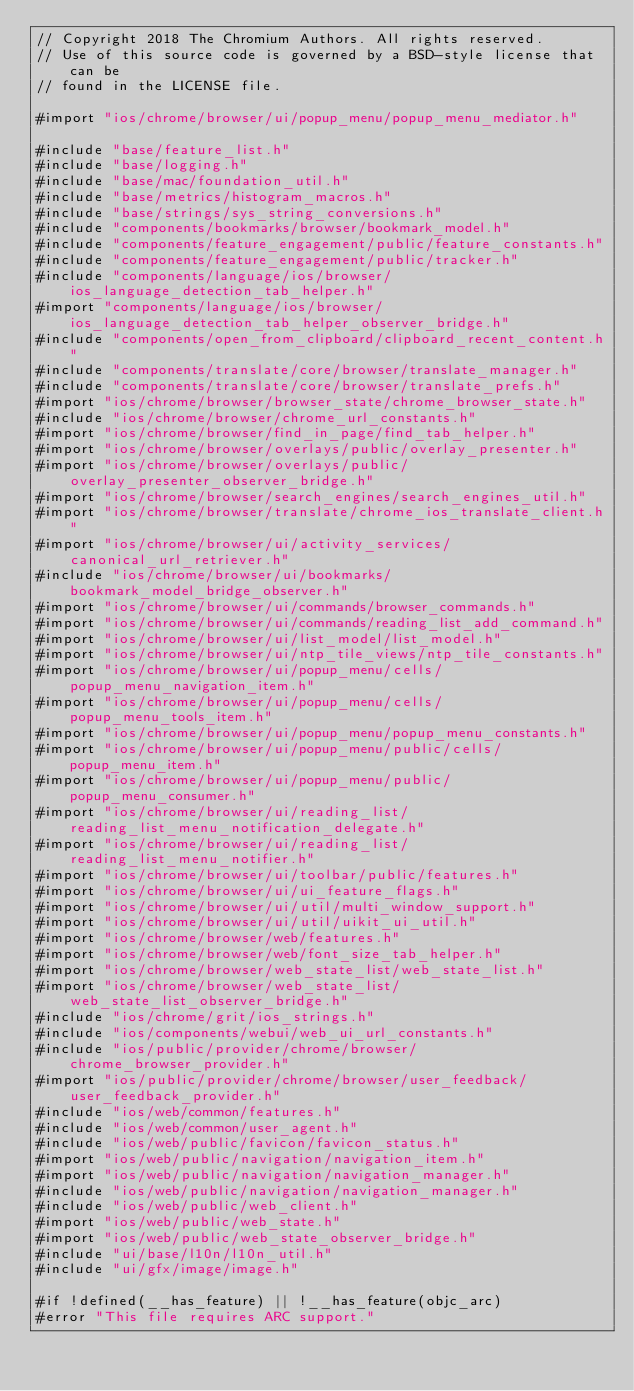<code> <loc_0><loc_0><loc_500><loc_500><_ObjectiveC_>// Copyright 2018 The Chromium Authors. All rights reserved.
// Use of this source code is governed by a BSD-style license that can be
// found in the LICENSE file.

#import "ios/chrome/browser/ui/popup_menu/popup_menu_mediator.h"

#include "base/feature_list.h"
#include "base/logging.h"
#include "base/mac/foundation_util.h"
#include "base/metrics/histogram_macros.h"
#include "base/strings/sys_string_conversions.h"
#include "components/bookmarks/browser/bookmark_model.h"
#include "components/feature_engagement/public/feature_constants.h"
#include "components/feature_engagement/public/tracker.h"
#include "components/language/ios/browser/ios_language_detection_tab_helper.h"
#import "components/language/ios/browser/ios_language_detection_tab_helper_observer_bridge.h"
#include "components/open_from_clipboard/clipboard_recent_content.h"
#include "components/translate/core/browser/translate_manager.h"
#include "components/translate/core/browser/translate_prefs.h"
#import "ios/chrome/browser/browser_state/chrome_browser_state.h"
#include "ios/chrome/browser/chrome_url_constants.h"
#import "ios/chrome/browser/find_in_page/find_tab_helper.h"
#import "ios/chrome/browser/overlays/public/overlay_presenter.h"
#import "ios/chrome/browser/overlays/public/overlay_presenter_observer_bridge.h"
#import "ios/chrome/browser/search_engines/search_engines_util.h"
#import "ios/chrome/browser/translate/chrome_ios_translate_client.h"
#import "ios/chrome/browser/ui/activity_services/canonical_url_retriever.h"
#include "ios/chrome/browser/ui/bookmarks/bookmark_model_bridge_observer.h"
#import "ios/chrome/browser/ui/commands/browser_commands.h"
#import "ios/chrome/browser/ui/commands/reading_list_add_command.h"
#import "ios/chrome/browser/ui/list_model/list_model.h"
#import "ios/chrome/browser/ui/ntp_tile_views/ntp_tile_constants.h"
#import "ios/chrome/browser/ui/popup_menu/cells/popup_menu_navigation_item.h"
#import "ios/chrome/browser/ui/popup_menu/cells/popup_menu_tools_item.h"
#import "ios/chrome/browser/ui/popup_menu/popup_menu_constants.h"
#import "ios/chrome/browser/ui/popup_menu/public/cells/popup_menu_item.h"
#import "ios/chrome/browser/ui/popup_menu/public/popup_menu_consumer.h"
#import "ios/chrome/browser/ui/reading_list/reading_list_menu_notification_delegate.h"
#import "ios/chrome/browser/ui/reading_list/reading_list_menu_notifier.h"
#import "ios/chrome/browser/ui/toolbar/public/features.h"
#import "ios/chrome/browser/ui/ui_feature_flags.h"
#import "ios/chrome/browser/ui/util/multi_window_support.h"
#import "ios/chrome/browser/ui/util/uikit_ui_util.h"
#import "ios/chrome/browser/web/features.h"
#import "ios/chrome/browser/web/font_size_tab_helper.h"
#import "ios/chrome/browser/web_state_list/web_state_list.h"
#import "ios/chrome/browser/web_state_list/web_state_list_observer_bridge.h"
#include "ios/chrome/grit/ios_strings.h"
#include "ios/components/webui/web_ui_url_constants.h"
#include "ios/public/provider/chrome/browser/chrome_browser_provider.h"
#import "ios/public/provider/chrome/browser/user_feedback/user_feedback_provider.h"
#include "ios/web/common/features.h"
#include "ios/web/common/user_agent.h"
#include "ios/web/public/favicon/favicon_status.h"
#import "ios/web/public/navigation/navigation_item.h"
#import "ios/web/public/navigation/navigation_manager.h"
#include "ios/web/public/navigation/navigation_manager.h"
#include "ios/web/public/web_client.h"
#import "ios/web/public/web_state.h"
#import "ios/web/public/web_state_observer_bridge.h"
#include "ui/base/l10n/l10n_util.h"
#include "ui/gfx/image/image.h"

#if !defined(__has_feature) || !__has_feature(objc_arc)
#error "This file requires ARC support."</code> 